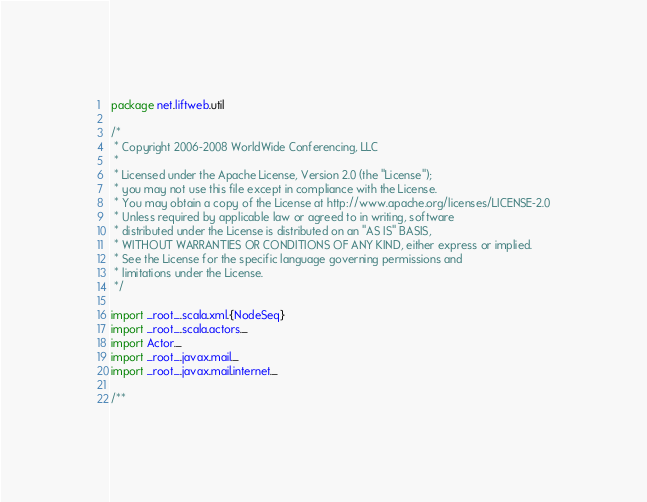<code> <loc_0><loc_0><loc_500><loc_500><_Scala_>package net.liftweb.util

/*
 * Copyright 2006-2008 WorldWide Conferencing, LLC
 *
 * Licensed under the Apache License, Version 2.0 (the "License");
 * you may not use this file except in compliance with the License.
 * You may obtain a copy of the License at http://www.apache.org/licenses/LICENSE-2.0
 * Unless required by applicable law or agreed to in writing, software
 * distributed under the License is distributed on an "AS IS" BASIS,
 * WITHOUT WARRANTIES OR CONDITIONS OF ANY KIND, either express or implied.
 * See the License for the specific language governing permissions and
 * limitations under the License.
 */

import _root_.scala.xml.{NodeSeq}
import _root_.scala.actors._
import Actor._
import _root_.javax.mail._
import _root_.javax.mail.internet._

/**</code> 